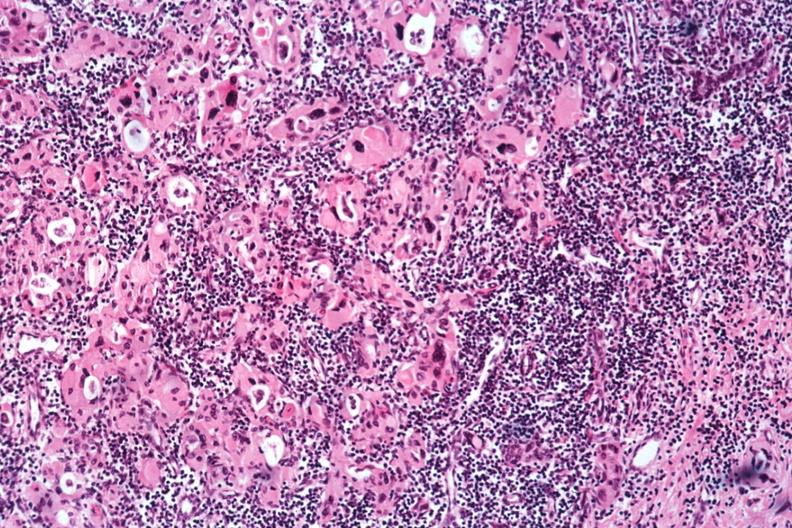s acid present?
Answer the question using a single word or phrase. No 